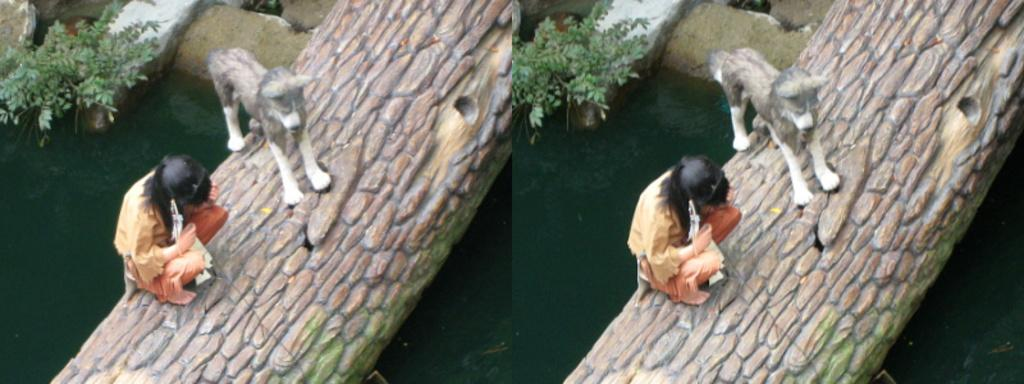What type of artwork is the image? The image is a collage. What can be seen in the collage? There is a wooden structure, a dog, a girl, water, a plant, and stones in the image. What are the dog and girl doing in the image? The dog and girl are sitting on the wooden structure. Where is the plant located in the image? The plant is in the top left corner of the image. What type of power source is visible in the image? There is no power source visible in the image. How many teeth can be seen on the dog in the image? The image does not show the dog's teeth, so it is not possible to determine the number of teeth. 